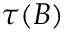Convert formula to latex. <formula><loc_0><loc_0><loc_500><loc_500>\tau ( B )</formula> 